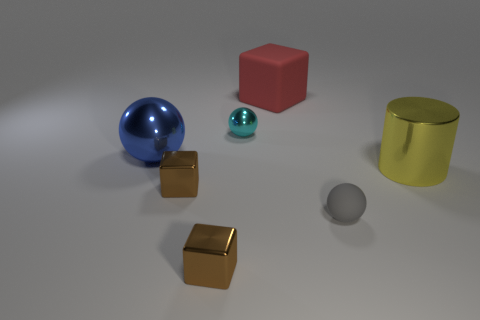Add 2 small green objects. How many objects exist? 9 Subtract all cylinders. How many objects are left? 6 Subtract all balls. Subtract all green metal objects. How many objects are left? 4 Add 2 large red objects. How many large red objects are left? 3 Add 3 red rubber blocks. How many red rubber blocks exist? 4 Subtract 0 green balls. How many objects are left? 7 